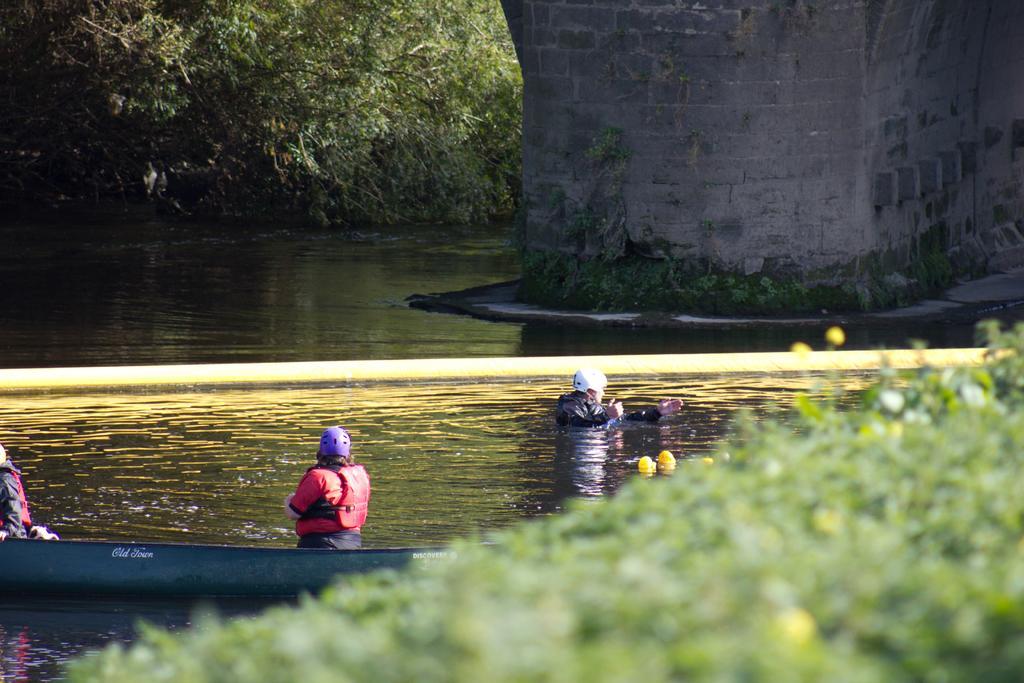Can you describe this image briefly? The foreground is blurred. In the foreground there is greenery. In the center of the picture there is water, in the water there are people and a boat. In the background there are trees and a construction. 